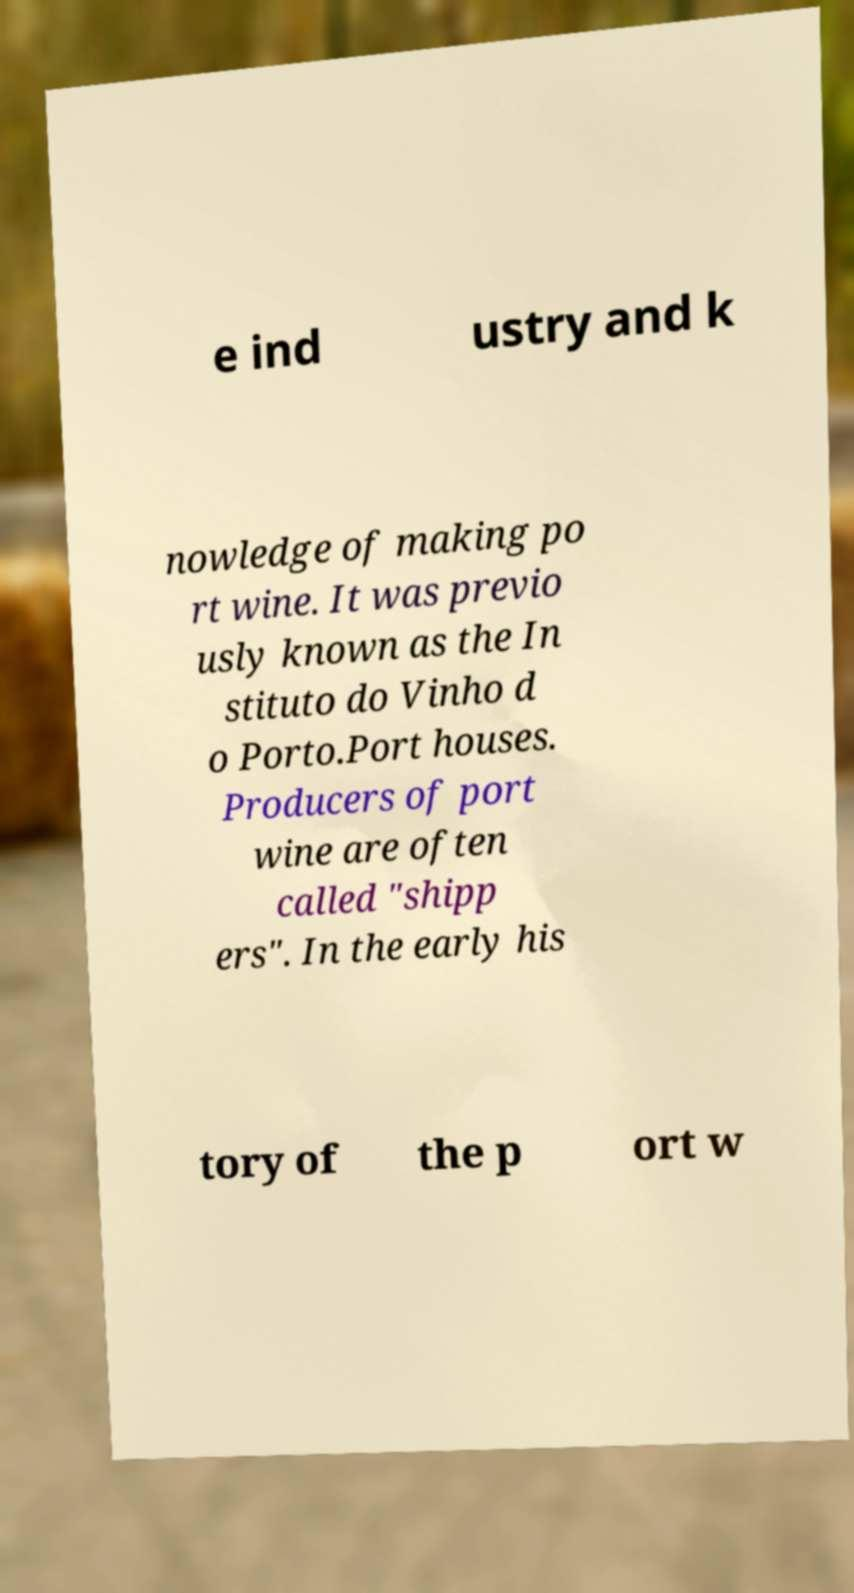Could you extract and type out the text from this image? e ind ustry and k nowledge of making po rt wine. It was previo usly known as the In stituto do Vinho d o Porto.Port houses. Producers of port wine are often called "shipp ers". In the early his tory of the p ort w 